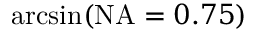Convert formula to latex. <formula><loc_0><loc_0><loc_500><loc_500>\arcsin ( N A = 0 . 7 5 )</formula> 